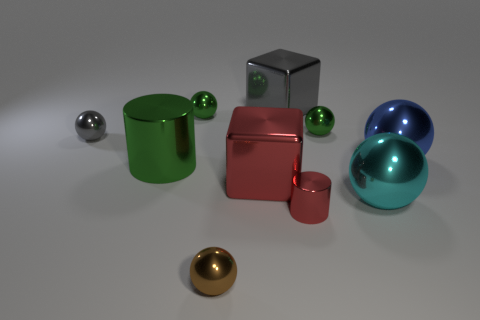What number of things are spheres that are behind the red shiny cylinder or tiny red rubber cylinders?
Provide a succinct answer. 5. Does the small thing on the right side of the small red metallic cylinder have the same color as the large metal cylinder?
Your response must be concise. Yes. What shape is the red object right of the large block that is behind the big blue sphere?
Your answer should be compact. Cylinder. Are there fewer tiny red cylinders that are to the right of the cyan ball than large gray things left of the small brown object?
Make the answer very short. No. The brown thing that is the same shape as the tiny gray metal thing is what size?
Your answer should be very brief. Small. How many objects are either tiny objects behind the big green metal cylinder or small shiny spheres that are behind the blue ball?
Keep it short and to the point. 3. Do the brown object and the green cylinder have the same size?
Give a very brief answer. No. Is the number of tiny green shiny blocks greater than the number of big shiny cylinders?
Your answer should be very brief. No. What number of other things are the same color as the small metallic cylinder?
Your answer should be compact. 1. What number of things are either large red metal objects or large green things?
Offer a terse response. 2. 